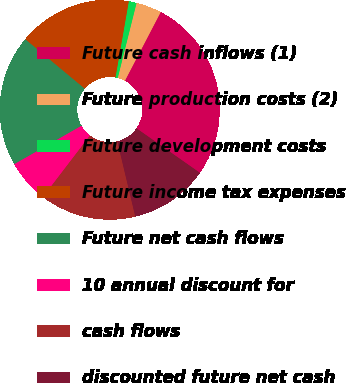Convert chart to OTSL. <chart><loc_0><loc_0><loc_500><loc_500><pie_chart><fcel>Future cash inflows (1)<fcel>Future production costs (2)<fcel>Future development costs<fcel>Future income tax expenses<fcel>Future net cash flows<fcel>10 annual discount for<fcel>cash flows<fcel>discounted future net cash<nl><fcel>27.09%<fcel>3.74%<fcel>1.15%<fcel>16.72%<fcel>19.31%<fcel>6.34%<fcel>14.12%<fcel>11.53%<nl></chart> 